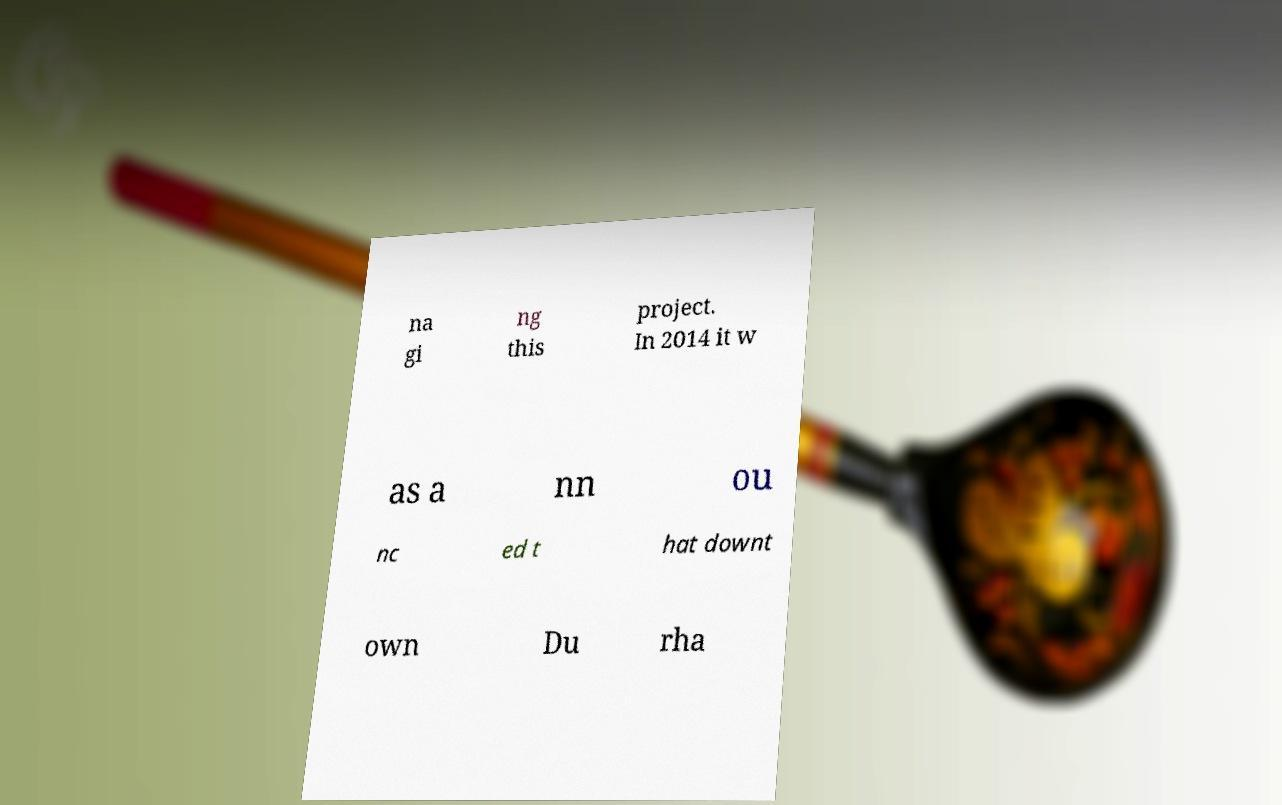Please read and relay the text visible in this image. What does it say? na gi ng this project. In 2014 it w as a nn ou nc ed t hat downt own Du rha 